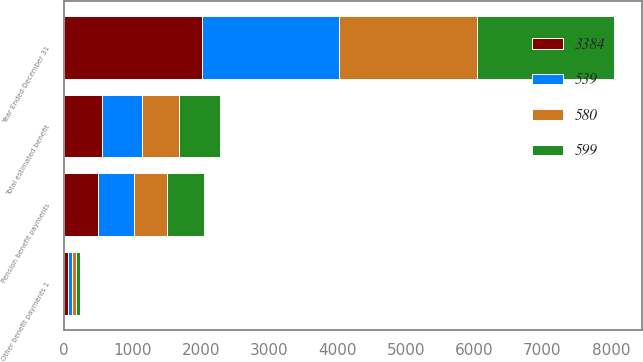<chart> <loc_0><loc_0><loc_500><loc_500><stacked_bar_chart><ecel><fcel>Year Ended December 31<fcel>Pension benefit payments<fcel>Other benefit payments 1<fcel>Total estimated benefit<nl><fcel>580<fcel>2012<fcel>486<fcel>53<fcel>539<nl><fcel>3384<fcel>2013<fcel>501<fcel>56<fcel>557<nl><fcel>539<fcel>2014<fcel>521<fcel>59<fcel>580<nl><fcel>599<fcel>2015<fcel>537<fcel>62<fcel>599<nl></chart> 